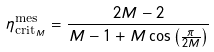<formula> <loc_0><loc_0><loc_500><loc_500>\eta ^ { \text {mes} } _ { \text {crit} _ { M } } = \frac { 2 M - 2 } { M - 1 + M \cos \left ( \frac { \pi } { 2 M } \right ) }</formula> 